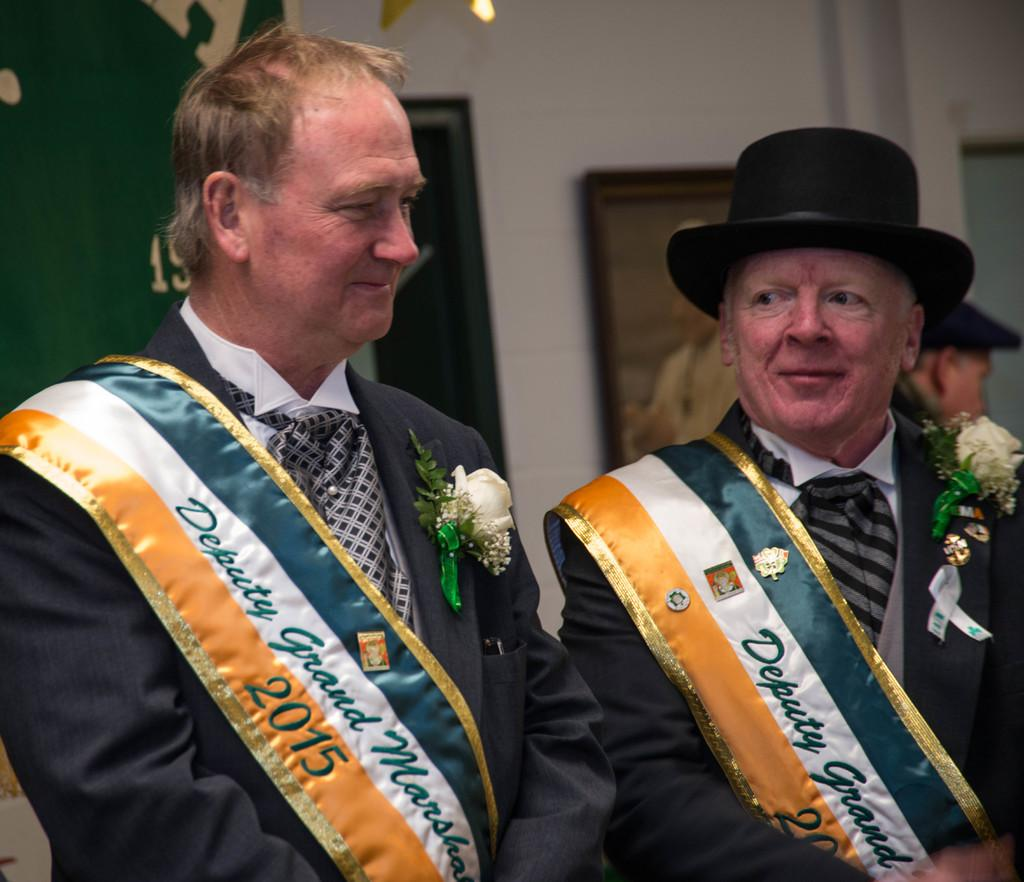How many people are visible in the image? There are two persons standing and smiling in the image. Can you describe the expressions of the people in the image? The two persons are smiling in the image. What can be seen in the background of the image? There is another person and frames attached to the wall in the background of the image. What word is the person in the background saying in the image? There is no indication of any words being spoken in the image, so it cannot be determined. 